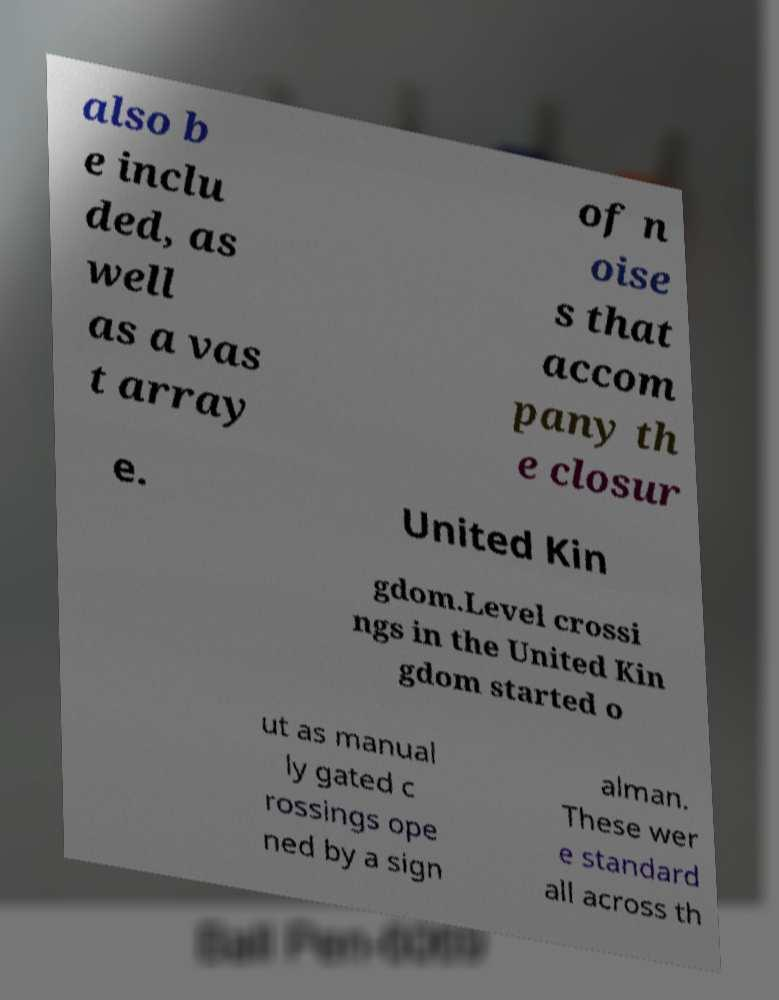Can you accurately transcribe the text from the provided image for me? also b e inclu ded, as well as a vas t array of n oise s that accom pany th e closur e. United Kin gdom.Level crossi ngs in the United Kin gdom started o ut as manual ly gated c rossings ope ned by a sign alman. These wer e standard all across th 